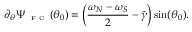<formula> <loc_0><loc_0><loc_500><loc_500>\partial _ { \theta } \Psi _ { F C } ( \theta _ { 0 } ) = \left ( \frac { \omega _ { N } - \omega _ { S } } { 2 } - \widetilde { \gamma } \right ) \sin ( \theta _ { 0 } ) .</formula> 